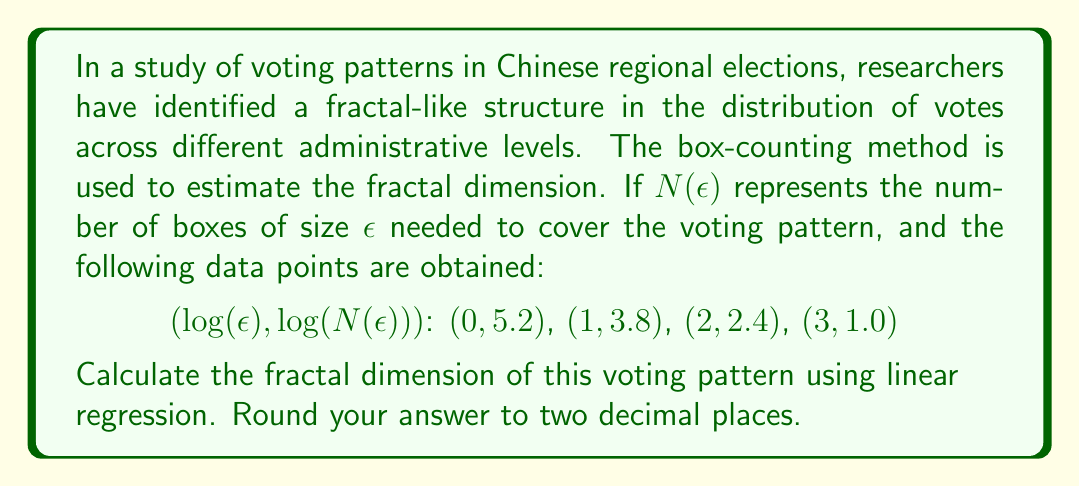Can you answer this question? To calculate the fractal dimension using the box-counting method and linear regression, we follow these steps:

1) The fractal dimension $D$ is given by the slope of the line when $\log(N(\epsilon))$ is plotted against $\log(\epsilon)$.

2) We use the formula for the slope in linear regression:

   $$D = -\frac{n\sum_{i=1}^n x_iy_i - \sum_{i=1}^n x_i \sum_{i=1}^n y_i}{n\sum_{i=1}^n x_i^2 - (\sum_{i=1}^n x_i)^2}$$

   where $x_i = \log(\epsilon)$ and $y_i = \log(N(\epsilon))$

3) From the given data:
   $n = 4$
   $\sum x_i = 0 + 1 + 2 + 3 = 6$
   $\sum y_i = 5.2 + 3.8 + 2.4 + 1.0 = 12.4$
   $\sum x_iy_i = 0(5.2) + 1(3.8) + 2(2.4) + 3(1.0) = 11.6$
   $\sum x_i^2 = 0^2 + 1^2 + 2^2 + 3^2 = 14$

4) Substituting these values into the formula:

   $$D = -\frac{4(11.6) - 6(12.4)}{4(14) - 6^2}$$

5) Simplifying:

   $$D = -\frac{46.4 - 74.4}{56 - 36} = \frac{28}{20} = 1.4$$

Therefore, the fractal dimension of the voting pattern is approximately 1.40.
Answer: 1.40 